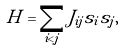Convert formula to latex. <formula><loc_0><loc_0><loc_500><loc_500>H = \sum _ { i < j } J _ { i j } s _ { i } s _ { j } ,</formula> 